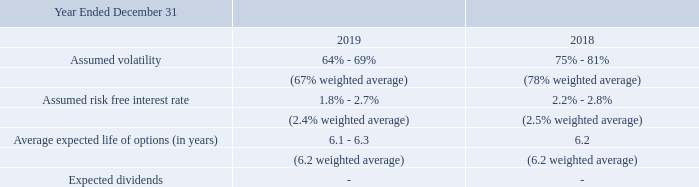As of December 31, 2019, exercisable options had an intrinsic value of less than $0.1 million. The intrinsic value of options exercised was $0.4 million in 2019 and $0.1 million in 2018. The following are the assumptions used in valuing the 2019 and 2018 stock option grants:
In January 2020, we issued options to employees for the purchase of up to 591,004 shares of common stock, at an exercise price of $1.23 per share which vest and become exercisable in four annual installments ending in January 2024. The options have a grant date fair value per share of $1.26.
As of December 31, 2019, what is the intrinsic value of the outstanding stock options? $0.1 million. What was the intrinsic value of options exercised in 2019 and 2018 respectively? $0.4 million, $0.1 million. What are the respective assumed volatility in 2018 and 2019 respectively? 75% - 81%, 64% - 69%. What is the average assumed risk free rate in 2018?
Answer scale should be: percent. (2.2 + 2.8)/2 
Answer: 2.5. What is the average assumed risk free rate in 2019?
Answer scale should be: percent. (1.8 + 2.7)/2 
Answer: 2.25. What is the average assumed volatility in 2018?
Answer scale should be: percent. (75 + 81)/2 
Answer: 78. 